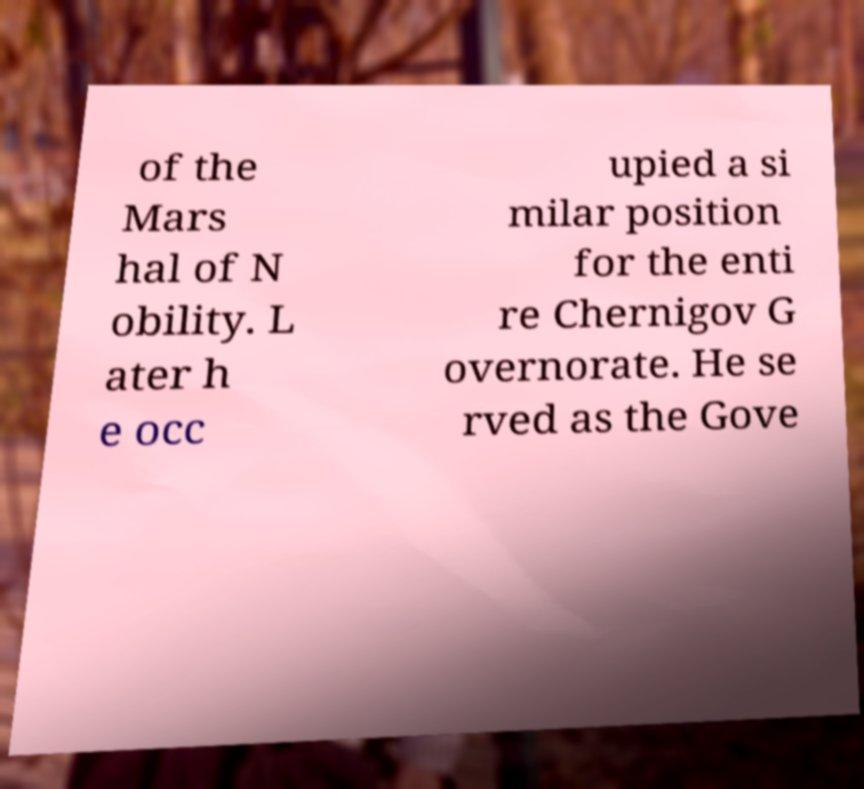For documentation purposes, I need the text within this image transcribed. Could you provide that? of the Mars hal of N obility. L ater h e occ upied a si milar position for the enti re Chernigov G overnorate. He se rved as the Gove 